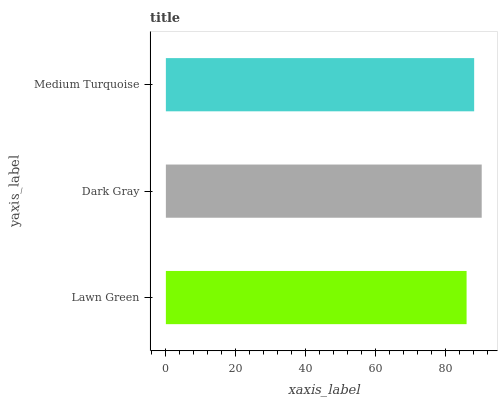Is Lawn Green the minimum?
Answer yes or no. Yes. Is Dark Gray the maximum?
Answer yes or no. Yes. Is Medium Turquoise the minimum?
Answer yes or no. No. Is Medium Turquoise the maximum?
Answer yes or no. No. Is Dark Gray greater than Medium Turquoise?
Answer yes or no. Yes. Is Medium Turquoise less than Dark Gray?
Answer yes or no. Yes. Is Medium Turquoise greater than Dark Gray?
Answer yes or no. No. Is Dark Gray less than Medium Turquoise?
Answer yes or no. No. Is Medium Turquoise the high median?
Answer yes or no. Yes. Is Medium Turquoise the low median?
Answer yes or no. Yes. Is Dark Gray the high median?
Answer yes or no. No. Is Dark Gray the low median?
Answer yes or no. No. 